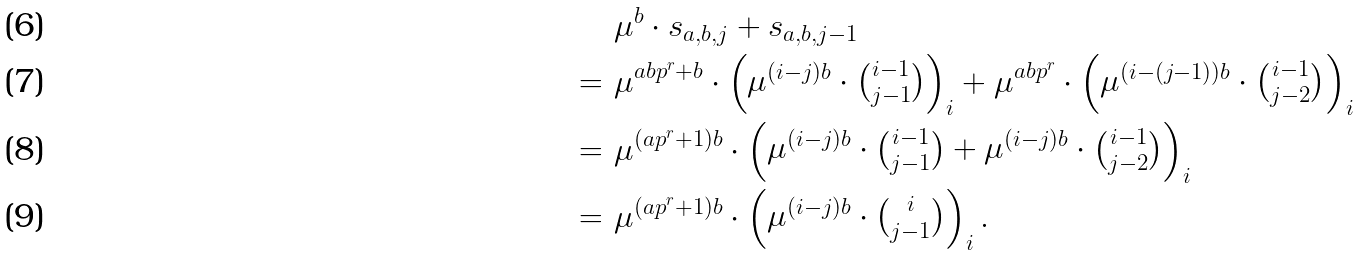Convert formula to latex. <formula><loc_0><loc_0><loc_500><loc_500>& & & \ \mu ^ { b } \cdot s _ { a , b , j } + s _ { a , b , j - 1 } \\ & & = & \ \mu ^ { a b p ^ { r } + b } \cdot \begin{pmatrix} \mu ^ { ( i - j ) b } \cdot { i - 1 \choose j - 1 } \end{pmatrix} _ { i } + \mu ^ { a b p ^ { r } } \cdot \begin{pmatrix} \mu ^ { ( i - ( j - 1 ) ) b } \cdot { i - 1 \choose j - 2 } \end{pmatrix} _ { i } \\ & & = & \ \mu ^ { ( a p ^ { r } + 1 ) b } \cdot \begin{pmatrix} \mu ^ { ( i - j ) b } \cdot { i - 1 \choose j - 1 } + \mu ^ { ( i - j ) b } \cdot { i - 1 \choose j - 2 } \end{pmatrix} _ { i } \\ & & = & \ \mu ^ { ( a p ^ { r } + 1 ) b } \cdot \begin{pmatrix} \mu ^ { ( i - j ) b } \cdot { i \choose j - 1 } \end{pmatrix} _ { i } .</formula> 